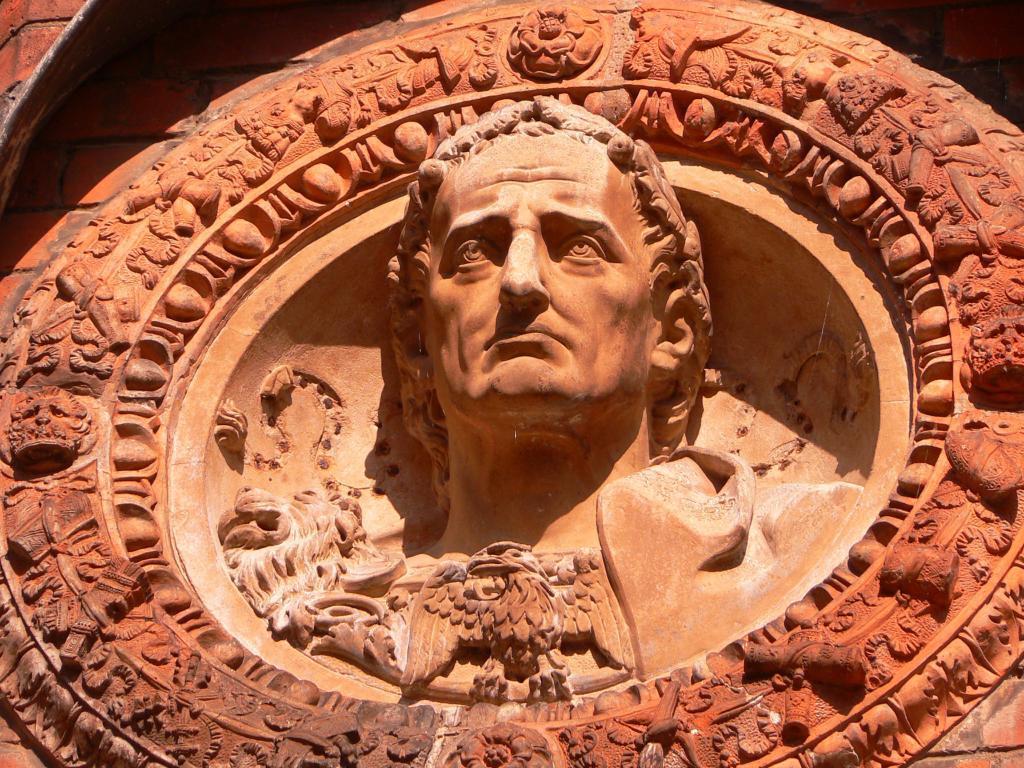How would you summarize this image in a sentence or two? In this picture there is a sculpture of a person which is in light orange color. 